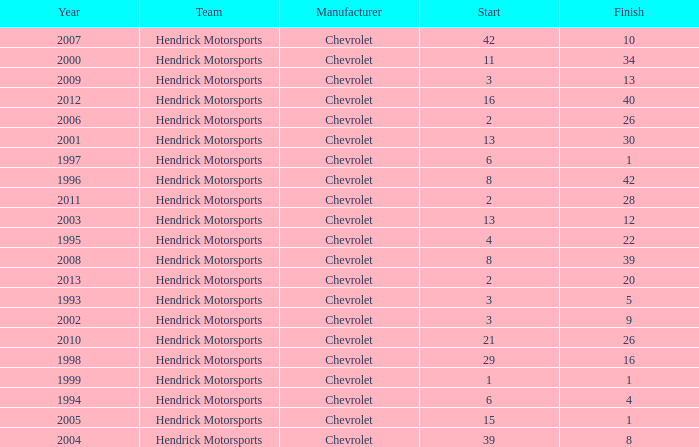Which team had a start of 8 in years under 2008? Hendrick Motorsports. 